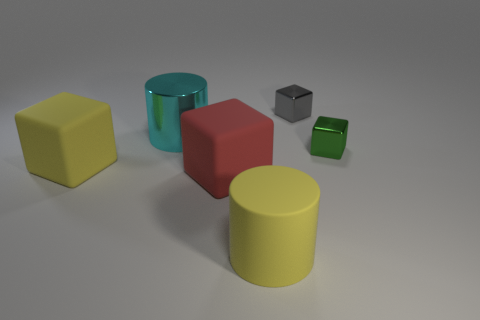What textures are visible on the surfaces of the objects? The objects exhibit a variety of textures: the large cylinder has a smooth, metallic finish indicative of a metal object, while the colored blocks appear to have a matte, almost plastic-like texture. 